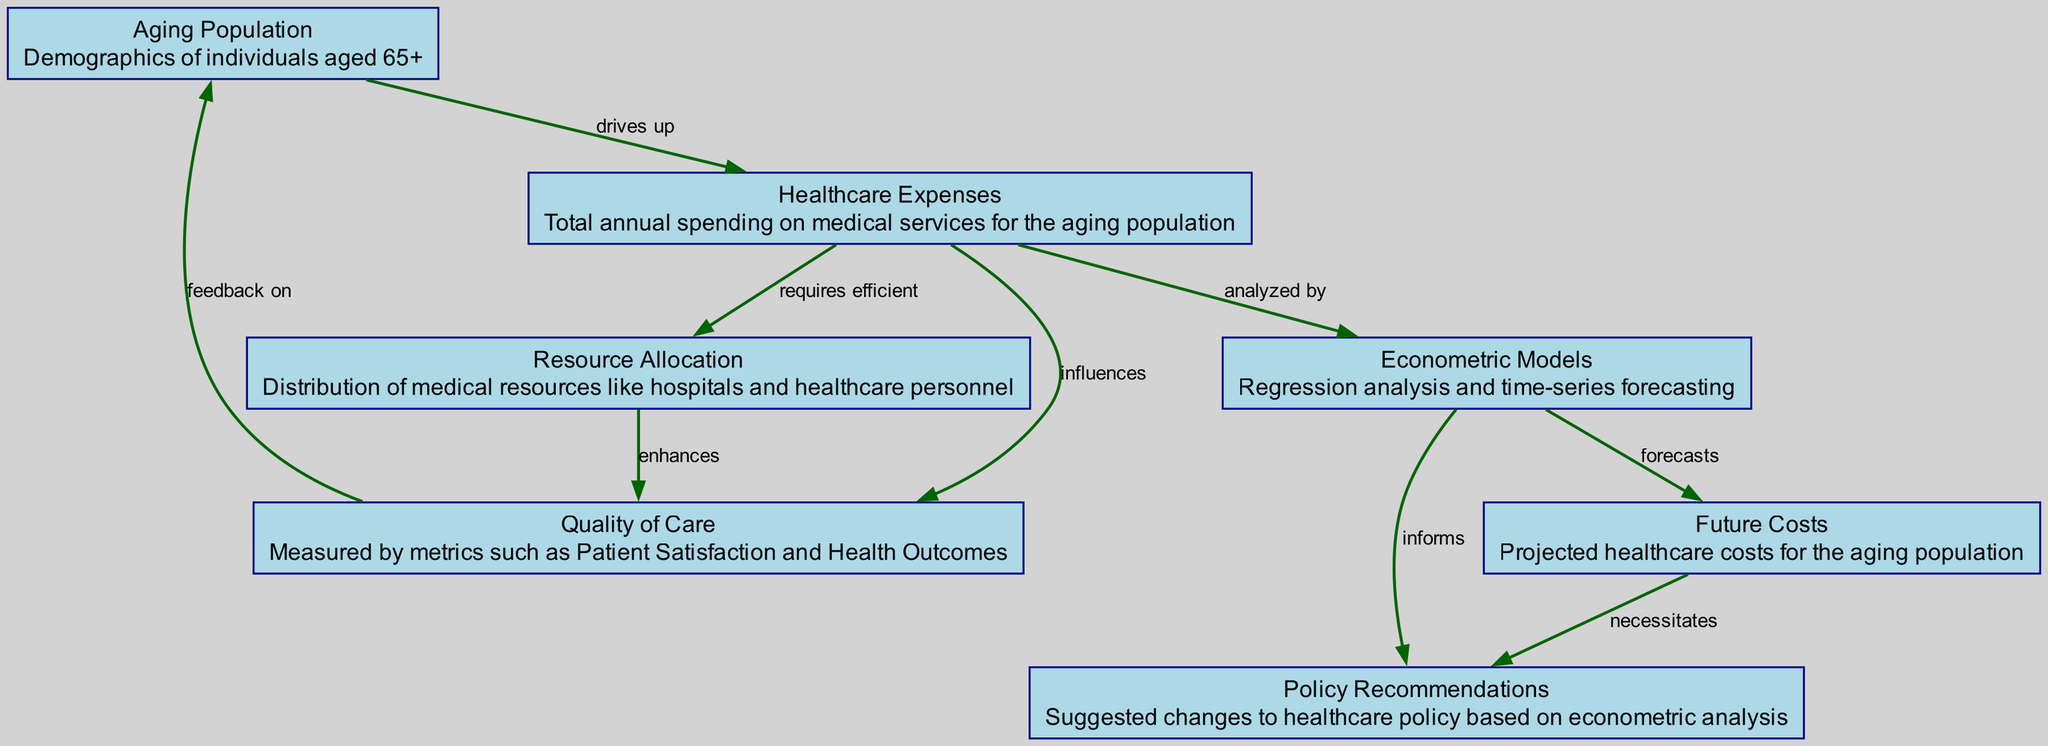What is the main demographic focus of the diagram? The diagram's central theme revolves around the "Aging Population," specifically individuals aged 65 and older, as denoted in the first node.
Answer: Aging Population How many nodes are present in the diagram? Counting the distinct elements labeled as nodes, we see a total of seven: Aging Population, Healthcare Expenses, Quality of Care, Resource Allocation, Econometric Models, Future Costs, and Policy Recommendations.
Answer: 7 What is the relationship labeled between Healthcare Expenses and Quality of Care? The diagram shows that Healthcare Expenses "influences" Quality of Care, indicating a direct effect of costs on care quality.
Answer: influences What does the node 'Econometric Models' inform as per the diagram? The arrow leading from Econometric Models indicates that it "informs" the node for Policy Recommendations, signifying that the econometric analysis affects policy suggestions.
Answer: Policy Recommendations What is forecasted by Econometric Models? The connection from Econometric Models to Future Costs explicitly states that these models "forecasts" the projected healthcare costs for the aging population, outlining an expected financial trend.
Answer: Future Costs How does Resource Allocation affect Quality of Care? The diagram indicates that Resource Allocation "enhances" Quality of Care, meaning that better distribution of resources is expected to improve care quality for the aging population.
Answer: enhances What necessitates Policy Recommendations in the diagram? The link from Future Costs shows that these costs "necessitates" Policy Recommendations, implying that anticipated healthcare expenses require adjustments in policy.
Answer: Future Costs Which node directly drives up Healthcare Expenses? The diagram identifies the node "Aging Population" to be the one that directly "drives up" Healthcare Expenses, illustrating the impact of an aging demographic on healthcare costs.
Answer: Aging Population What type of analysis do Econometric Models represent? The node label describes Econometric Models as involving "Regression analysis and time-series forecasting," indicating the analytical methods applied for predictions in the diagram.
Answer: Regression analysis and time-series forecasting 